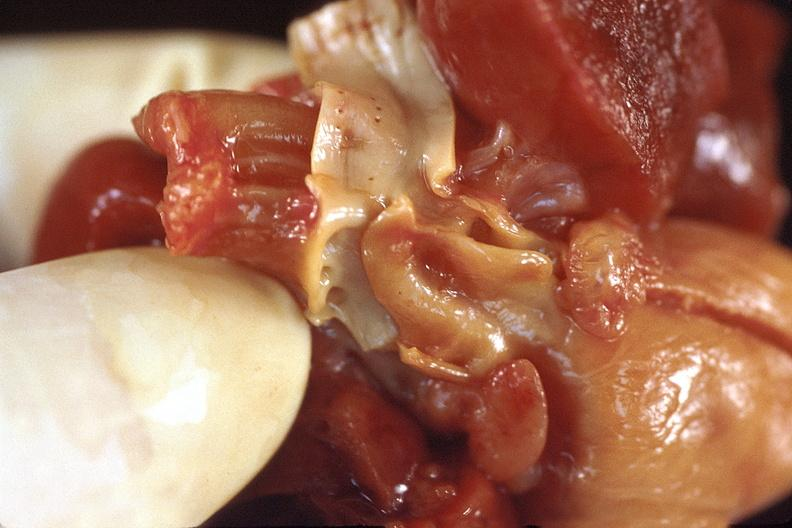s marfans syndrome present?
Answer the question using a single word or phrase. No 